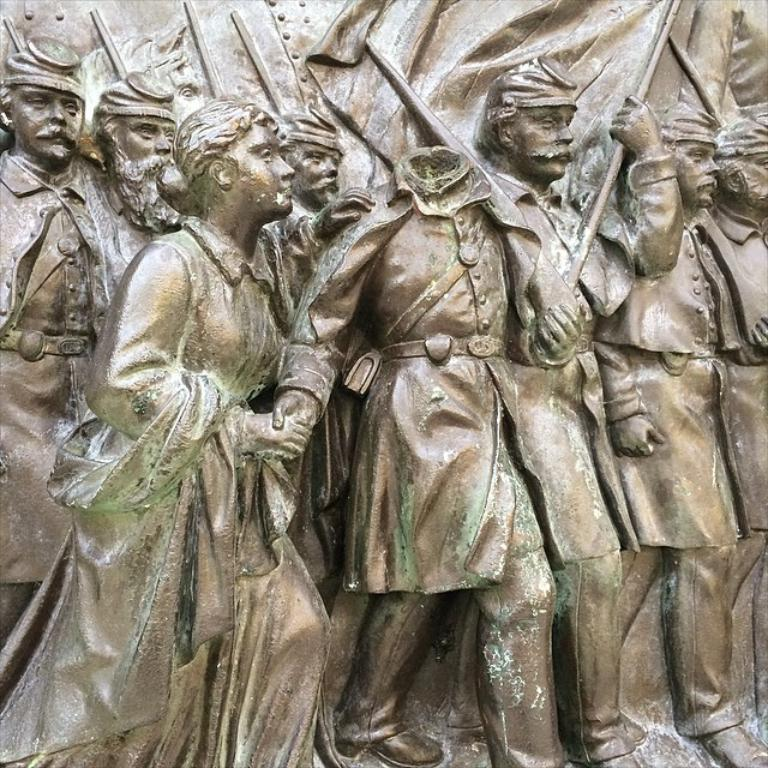What type of objects are depicted in the image? There are statues of people in the image. What type of bun is being used to hold the mint in the image? There is no bun or mint present in the image; it only features statues of people. 